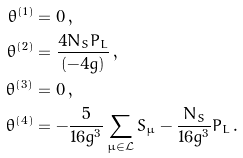<formula> <loc_0><loc_0><loc_500><loc_500>\theta ^ { ( 1 ) } & = 0 \, , \\ \theta ^ { ( 2 ) } & = \frac { 4 N _ { S } P _ { L } } { ( - 4 g ) } \, , \\ \theta ^ { ( 3 ) } & = 0 \, , \\ \theta ^ { ( 4 ) } & = - \frac { 5 } { 1 6 g ^ { 3 } } \sum _ { \mu \in \mathcal { L } } S _ { \mu } - \frac { N _ { S } } { 1 6 g ^ { 3 } } P _ { L } \, .</formula> 